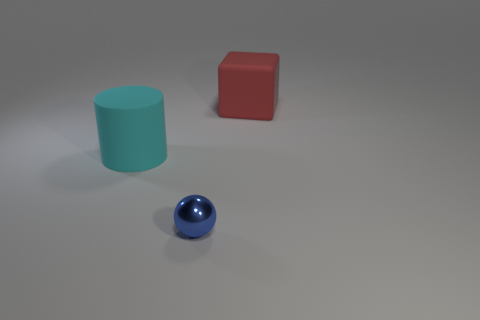How many objects are either big things behind the cyan matte object or large objects that are left of the blue shiny ball?
Keep it short and to the point. 2. How many things are either tiny blue metallic objects that are in front of the cylinder or tiny brown rubber objects?
Offer a very short reply. 1. What is the shape of the red object that is made of the same material as the big cylinder?
Offer a terse response. Cube. What number of other tiny things are the same shape as the tiny blue object?
Offer a terse response. 0. What is the sphere made of?
Keep it short and to the point. Metal. There is a cube; is its color the same as the large thing left of the shiny object?
Make the answer very short. No. What number of cubes are either red things or tiny blue metal objects?
Make the answer very short. 1. What is the color of the large rubber thing that is in front of the red rubber object?
Keep it short and to the point. Cyan. How many red matte things have the same size as the cylinder?
Your response must be concise. 1. There is a rubber thing that is right of the tiny blue metal ball; does it have the same shape as the large matte object left of the blue shiny sphere?
Keep it short and to the point. No. 